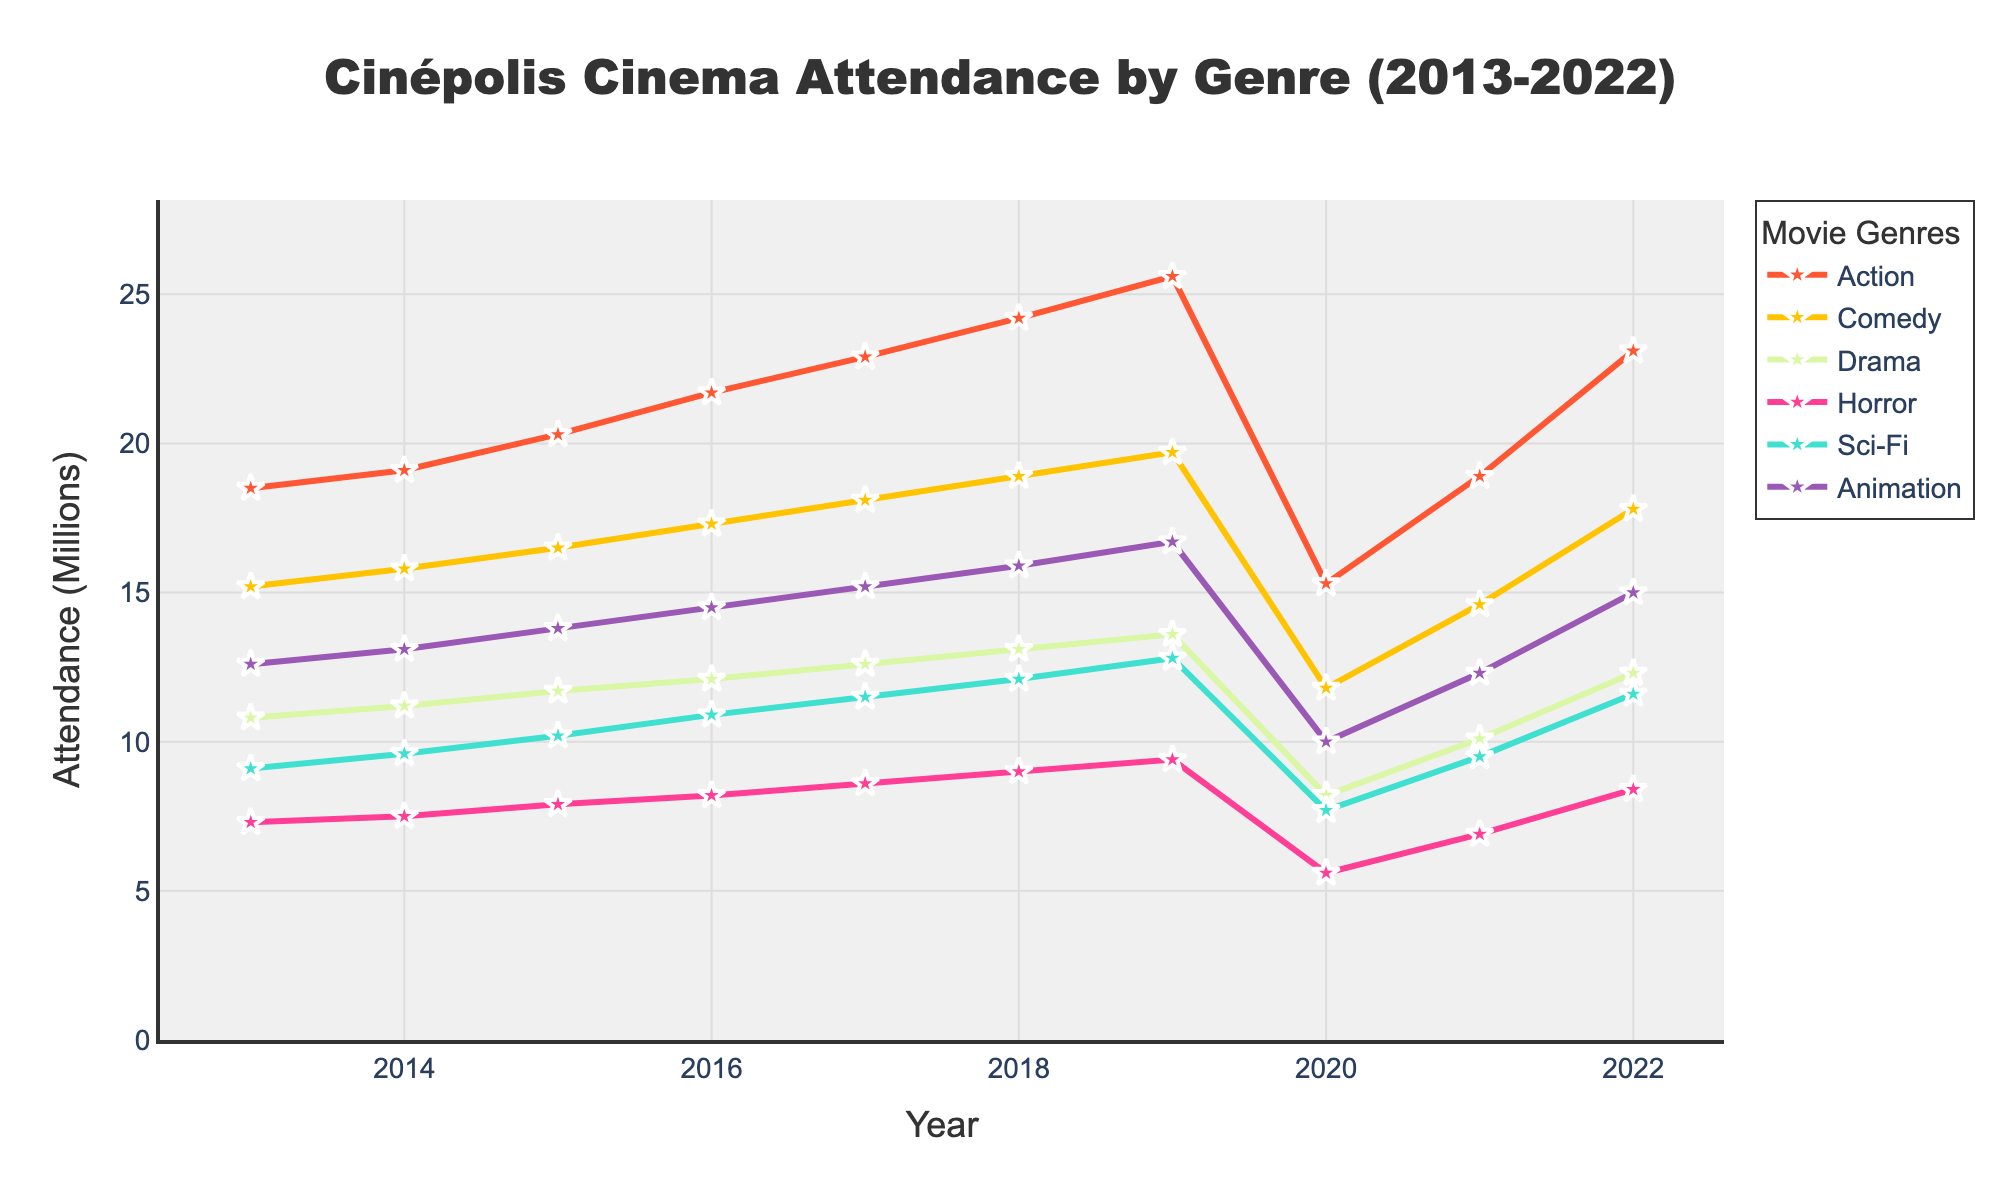What was the attendance for the Horror genre in 2020? Check the point for Horror genre in 2020 on the line, it shows the attendance is around 5.6 million
Answer: 5.6 million Which genre had the highest attendance in 2017? Compare the peaks of all genres for 2017, where Action genre has the highest peak
Answer: Action What was the overall trend for Comedy genre from 2013 to 2022? Observe the line for Comedy genre from left to right; it generally increases, drops in 2020, then rises again
Answer: Increasing with a dip in 2020 How much did Sci-Fi attendance increase from 2013 to 2019? Find the difference between the Sci-Fi attendance in 2019 (12.8 million) and 2013 (9.1 million)
Answer: 3.7 million Which genres experienced a drop in attendance from 2019 to 2020? Look for line segments with a downward slope between 2019 and 2020: Action, Comedy, Drama, Horror, Sci-Fi, and Animation all show drops
Answer: Action, Comedy, Drama, Horror, Sci-Fi, Animation What is the average attendance for the Drama genre over the decade? Sum all the attendance values for Drama from 2013 to 2022 (10.8+11.2+11.7+12.1+12.6+13.1+13.6+8.2+10.1+12.3) and then divide by 10
Answer: 11.57 million Between Action and Animation, which had a more significant drop in 2020? Find the difference in attendance for both genres between 2019 and 2020: Action (25.6-15.3=10.3 million), Animation (16.7-10.0=6.7 million); Action had a larger drop
Answer: Action In which years did all genres show an increase in attendance? Look for years where all lines show an upward trend from the previous year: 2014, 2015, 2016, 2017, 2018, 2019
Answer: 2014, 2015, 2016, 2017, 2018, 2019 